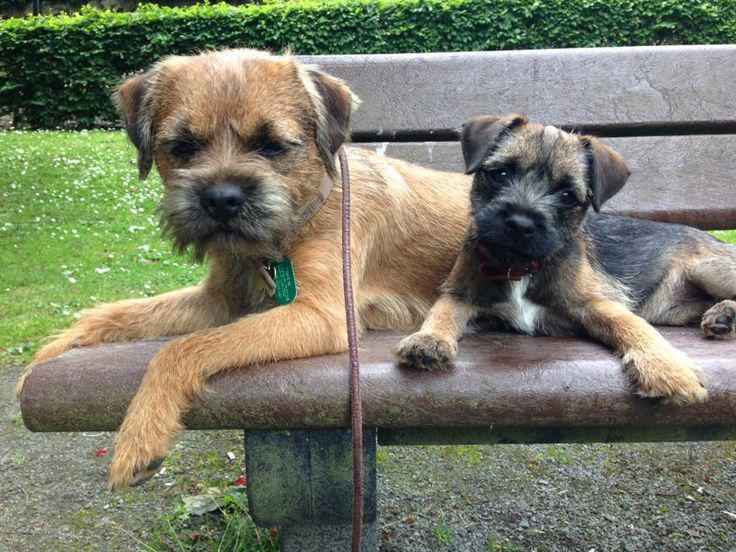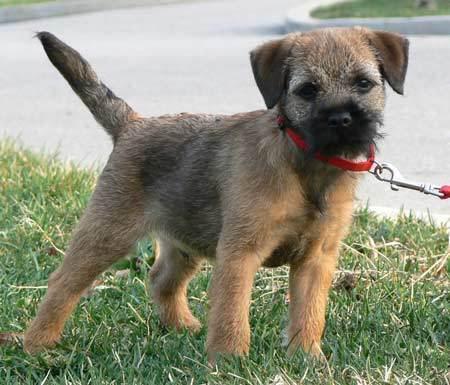The first image is the image on the left, the second image is the image on the right. Analyze the images presented: Is the assertion "Each image shows one person with exactly one dog, and one image shows a person propping the dog's chin with one hand." valid? Answer yes or no. No. The first image is the image on the left, the second image is the image on the right. For the images displayed, is the sentence "There are at most two dogs." factually correct? Answer yes or no. No. 